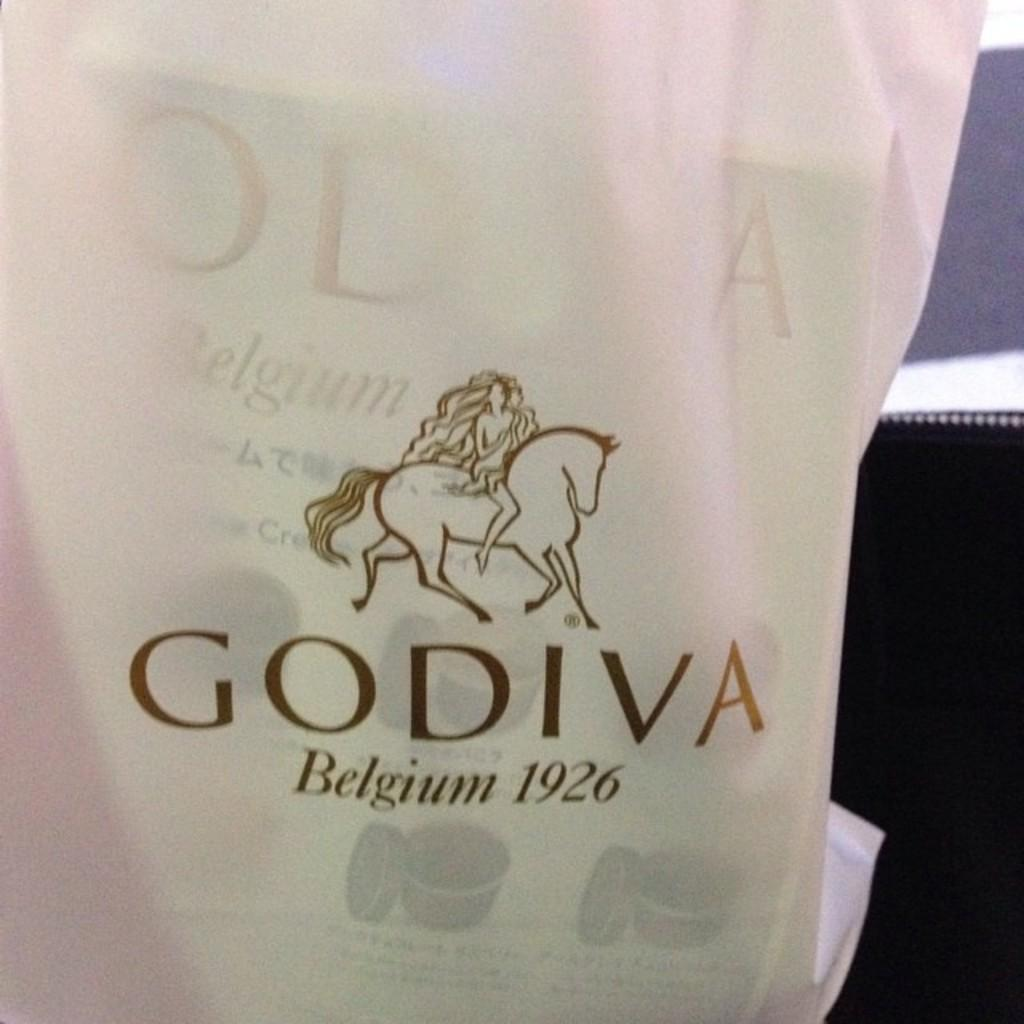Provide a one-sentence caption for the provided image. A Godiva bag with a horse on it. 